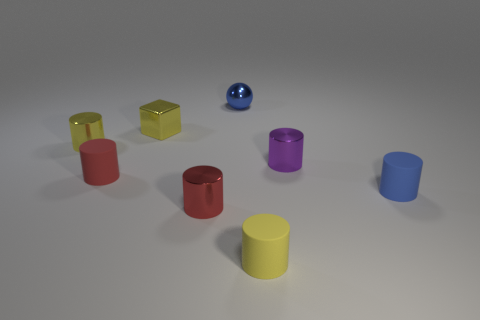Subtract all tiny red shiny cylinders. How many cylinders are left? 5 Subtract all yellow cylinders. How many cylinders are left? 4 Add 1 small blue things. How many objects exist? 9 Subtract all cubes. How many objects are left? 7 Subtract 1 spheres. How many spheres are left? 0 Subtract all cyan cylinders. Subtract all yellow cubes. How many cylinders are left? 6 Subtract all gray balls. How many red cylinders are left? 2 Subtract all small red cylinders. Subtract all red shiny cylinders. How many objects are left? 5 Add 3 small yellow things. How many small yellow things are left? 6 Add 8 tiny yellow cylinders. How many tiny yellow cylinders exist? 10 